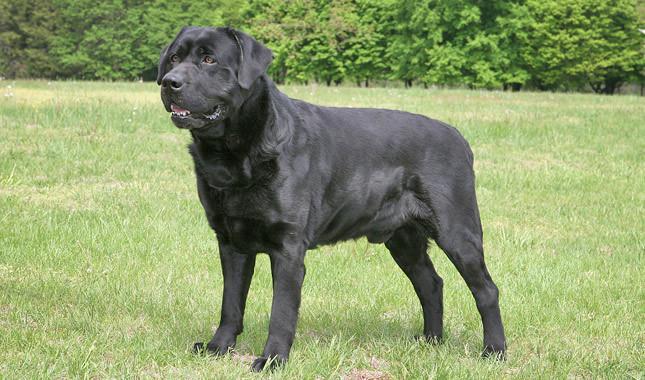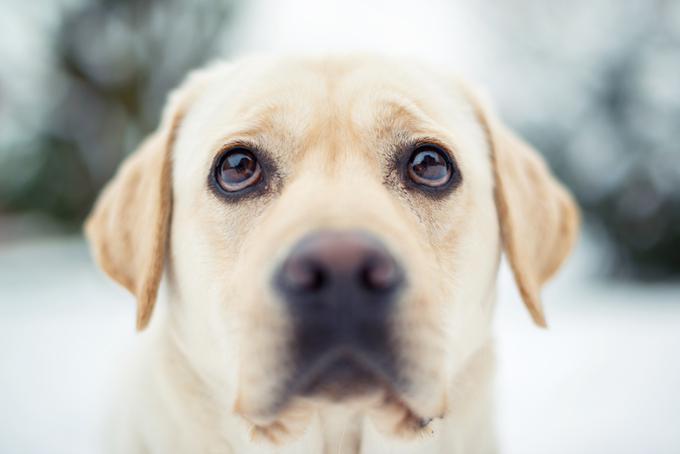The first image is the image on the left, the second image is the image on the right. Evaluate the accuracy of this statement regarding the images: "In 1 of the images, a dog is standing on grass.". Is it true? Answer yes or no. Yes. 